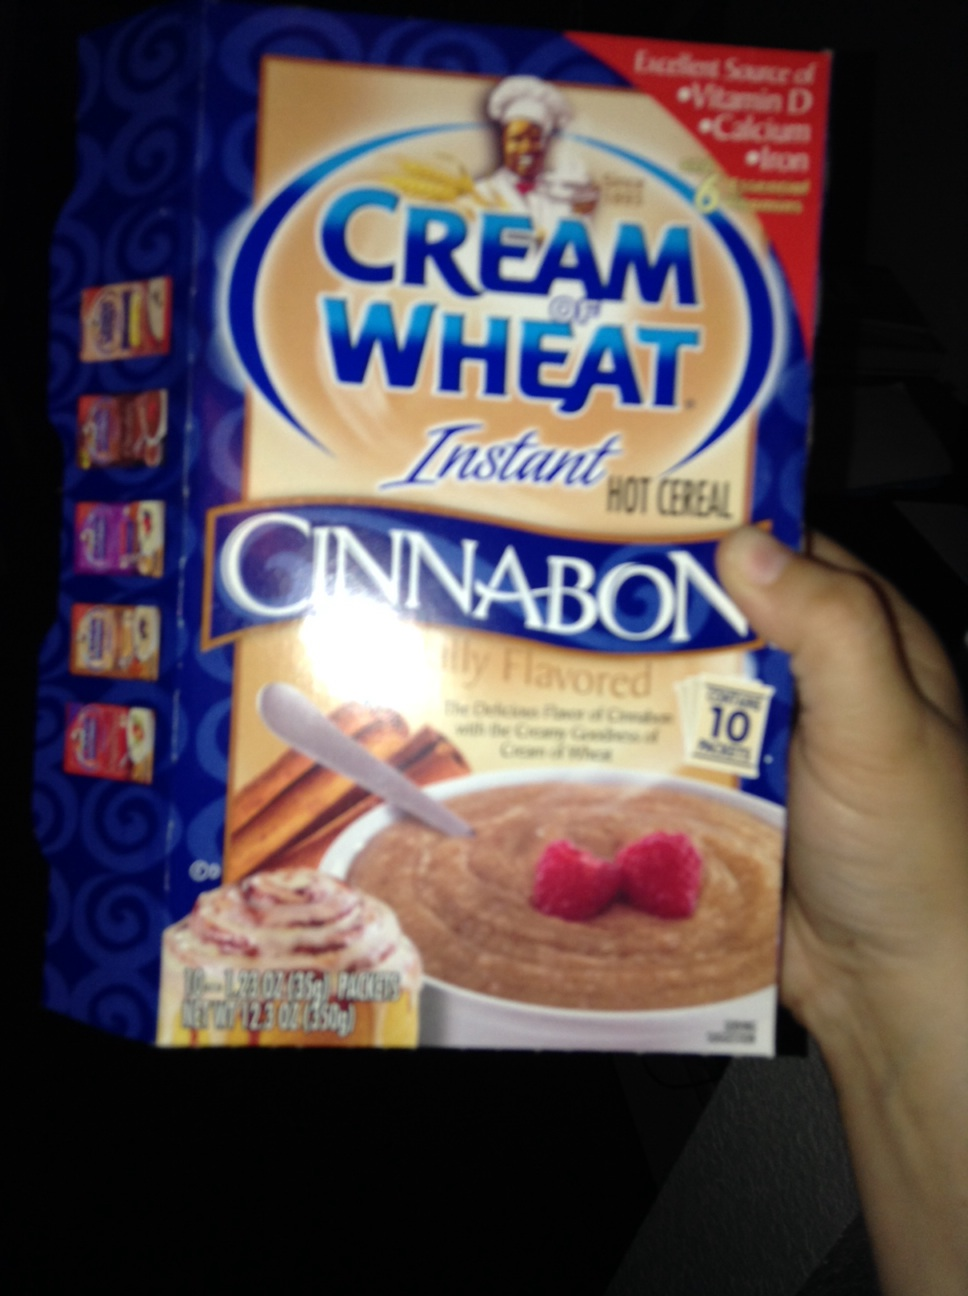What flavor of cream of wheat is this? The flavor of the Cream of Wheat shown in the image is 'Cinnabon'. This features the classic taste of cinnamon rolls, which includes the delicious flavors of cinnamon paired with creamy icing as depicted on the box. 